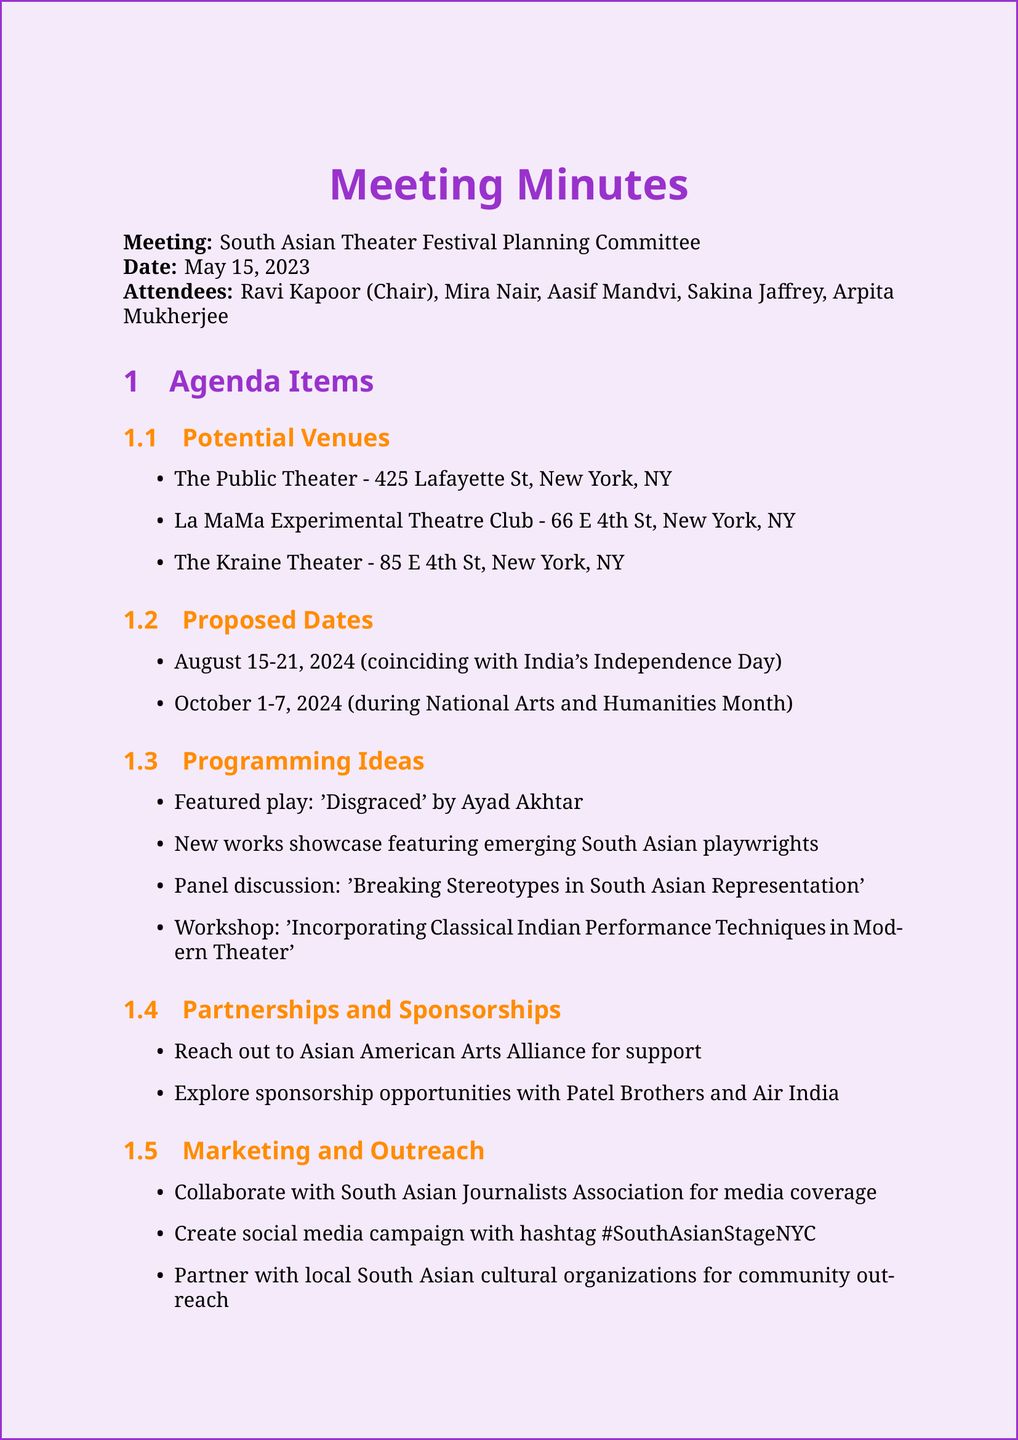What is the title of the meeting? The title of the meeting is stated at the beginning of the document.
Answer: South Asian Theater Festival Planning Committee Who is the chair of the meeting? The document lists Ravi Kapoor as the chair among the attendees.
Answer: Ravi Kapoor What are the proposed dates for the festival? The document details two potential date ranges for the festival.
Answer: August 15-21, 2024 What is one of the programming ideas discussed? The document mentions programming ideas for the festival, including specific plays and workshops.
Answer: Featured play: 'Disgraced' by Ayad Akhtar Which venue is suggested located at 425 Lafayette St? The document lists several venues, naming their addresses.
Answer: The Public Theater Who is responsible for drafting the marketing plan? The action items specify responsibilities assigned to attendees following the meeting.
Answer: Sakina What is the proposed social media hashtag for the festival? The document includes details about marketing strategies and social media campaigns.
Answer: #SouthAsianStageNYC How many attendees were present at the meeting? The document lists all individuals who attended the meeting.
Answer: Five What organization should be contacted for support? The document mentions a specific organization for partnerships and sponsorships.
Answer: Asian American Arts Alliance 